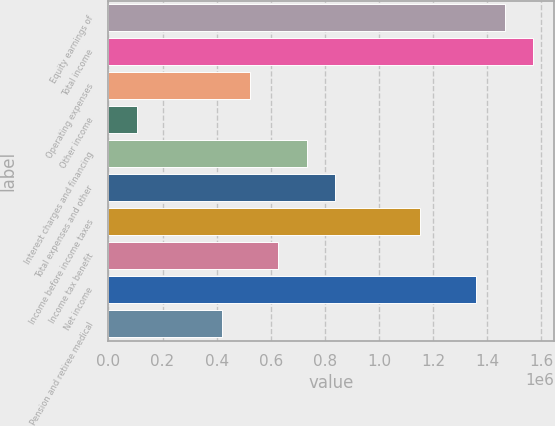<chart> <loc_0><loc_0><loc_500><loc_500><bar_chart><fcel>Equity earnings of<fcel>Total income<fcel>Operating expenses<fcel>Other income<fcel>Interest charges and financing<fcel>Total expenses and other<fcel>Income before income taxes<fcel>Income tax benefit<fcel>Net income<fcel>Pension and retiree medical<nl><fcel>1.4641e+06<fcel>1.56868e+06<fcel>522895<fcel>104580<fcel>732052<fcel>836631<fcel>1.15037e+06<fcel>627473<fcel>1.35952e+06<fcel>418316<nl></chart> 